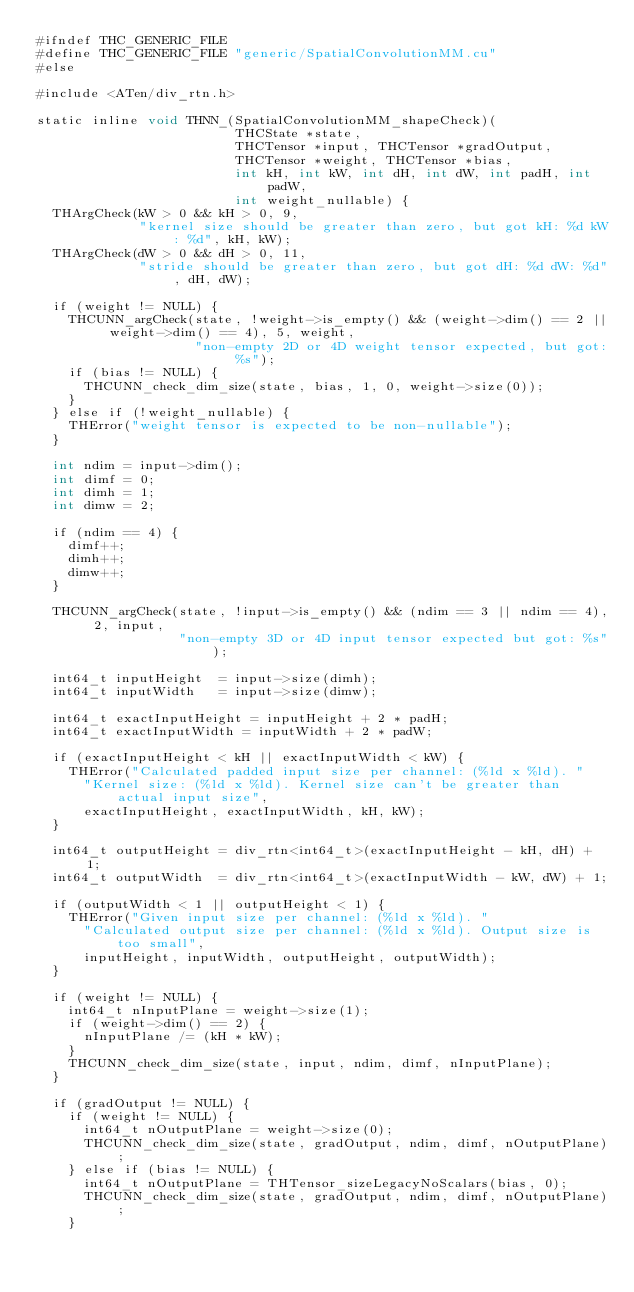Convert code to text. <code><loc_0><loc_0><loc_500><loc_500><_Cuda_>#ifndef THC_GENERIC_FILE
#define THC_GENERIC_FILE "generic/SpatialConvolutionMM.cu"
#else

#include <ATen/div_rtn.h>

static inline void THNN_(SpatialConvolutionMM_shapeCheck)(
                         THCState *state,
                         THCTensor *input, THCTensor *gradOutput,
                         THCTensor *weight, THCTensor *bias,
                         int kH, int kW, int dH, int dW, int padH, int padW,
                         int weight_nullable) {
  THArgCheck(kW > 0 && kH > 0, 9,
             "kernel size should be greater than zero, but got kH: %d kW: %d", kH, kW);
  THArgCheck(dW > 0 && dH > 0, 11,
             "stride should be greater than zero, but got dH: %d dW: %d", dH, dW);

  if (weight != NULL) {
    THCUNN_argCheck(state, !weight->is_empty() && (weight->dim() == 2 || weight->dim() == 4), 5, weight,
                    "non-empty 2D or 4D weight tensor expected, but got: %s");
    if (bias != NULL) {
      THCUNN_check_dim_size(state, bias, 1, 0, weight->size(0));
    }
  } else if (!weight_nullable) {
    THError("weight tensor is expected to be non-nullable");
  }

  int ndim = input->dim();
  int dimf = 0;
  int dimh = 1;
  int dimw = 2;

  if (ndim == 4) {
    dimf++;
    dimh++;
    dimw++;
  }

  THCUNN_argCheck(state, !input->is_empty() && (ndim == 3 || ndim == 4), 2, input,
                  "non-empty 3D or 4D input tensor expected but got: %s");

  int64_t inputHeight  = input->size(dimh);
  int64_t inputWidth   = input->size(dimw);

  int64_t exactInputHeight = inputHeight + 2 * padH;
  int64_t exactInputWidth = inputWidth + 2 * padW;

  if (exactInputHeight < kH || exactInputWidth < kW) {
    THError("Calculated padded input size per channel: (%ld x %ld). "
      "Kernel size: (%ld x %ld). Kernel size can't be greater than actual input size",
      exactInputHeight, exactInputWidth, kH, kW);
  }

  int64_t outputHeight = div_rtn<int64_t>(exactInputHeight - kH, dH) + 1;
  int64_t outputWidth  = div_rtn<int64_t>(exactInputWidth - kW, dW) + 1;

  if (outputWidth < 1 || outputHeight < 1) {
    THError("Given input size per channel: (%ld x %ld). "
      "Calculated output size per channel: (%ld x %ld). Output size is too small",
      inputHeight, inputWidth, outputHeight, outputWidth);
  }

  if (weight != NULL) {
    int64_t nInputPlane = weight->size(1);
    if (weight->dim() == 2) {
      nInputPlane /= (kH * kW);
    }
    THCUNN_check_dim_size(state, input, ndim, dimf, nInputPlane);
  }

  if (gradOutput != NULL) {
    if (weight != NULL) {
      int64_t nOutputPlane = weight->size(0);
      THCUNN_check_dim_size(state, gradOutput, ndim, dimf, nOutputPlane);
    } else if (bias != NULL) {
      int64_t nOutputPlane = THTensor_sizeLegacyNoScalars(bias, 0);
      THCUNN_check_dim_size(state, gradOutput, ndim, dimf, nOutputPlane);
    }</code> 